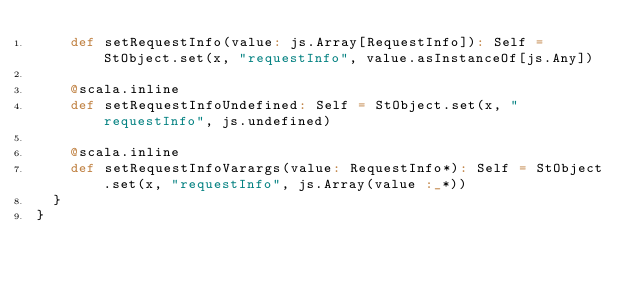<code> <loc_0><loc_0><loc_500><loc_500><_Scala_>    def setRequestInfo(value: js.Array[RequestInfo]): Self = StObject.set(x, "requestInfo", value.asInstanceOf[js.Any])
    
    @scala.inline
    def setRequestInfoUndefined: Self = StObject.set(x, "requestInfo", js.undefined)
    
    @scala.inline
    def setRequestInfoVarargs(value: RequestInfo*): Self = StObject.set(x, "requestInfo", js.Array(value :_*))
  }
}
</code> 